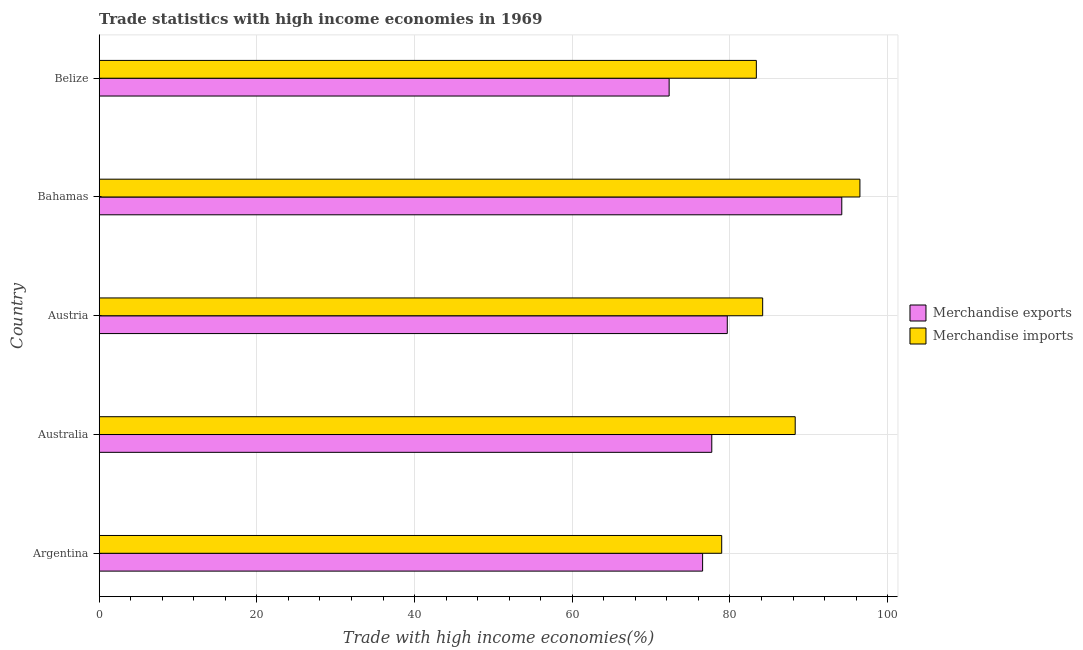How many different coloured bars are there?
Provide a succinct answer. 2. Are the number of bars per tick equal to the number of legend labels?
Your answer should be compact. Yes. How many bars are there on the 3rd tick from the top?
Offer a terse response. 2. In how many cases, is the number of bars for a given country not equal to the number of legend labels?
Ensure brevity in your answer.  0. What is the merchandise imports in Bahamas?
Offer a very short reply. 96.48. Across all countries, what is the maximum merchandise imports?
Give a very brief answer. 96.48. Across all countries, what is the minimum merchandise exports?
Your answer should be very brief. 72.28. In which country was the merchandise imports maximum?
Provide a succinct answer. Bahamas. In which country was the merchandise exports minimum?
Ensure brevity in your answer.  Belize. What is the total merchandise imports in the graph?
Give a very brief answer. 431.2. What is the difference between the merchandise imports in Australia and that in Austria?
Keep it short and to the point. 4.13. What is the difference between the merchandise exports in Australia and the merchandise imports in Austria?
Offer a very short reply. -6.45. What is the average merchandise exports per country?
Keep it short and to the point. 80.07. What is the difference between the merchandise imports and merchandise exports in Austria?
Offer a very short reply. 4.49. In how many countries, is the merchandise exports greater than 52 %?
Your answer should be compact. 5. What is the ratio of the merchandise exports in Australia to that in Bahamas?
Your response must be concise. 0.82. Is the merchandise exports in Bahamas less than that in Belize?
Your answer should be very brief. No. Is the difference between the merchandise imports in Argentina and Australia greater than the difference between the merchandise exports in Argentina and Australia?
Your answer should be very brief. No. What is the difference between the highest and the second highest merchandise exports?
Provide a short and direct response. 14.52. What is the difference between the highest and the lowest merchandise imports?
Ensure brevity in your answer.  17.53. What does the 1st bar from the bottom in Argentina represents?
Offer a terse response. Merchandise exports. How many bars are there?
Ensure brevity in your answer.  10. How many countries are there in the graph?
Offer a terse response. 5. Are the values on the major ticks of X-axis written in scientific E-notation?
Offer a very short reply. No. Does the graph contain any zero values?
Keep it short and to the point. No. Does the graph contain grids?
Your response must be concise. Yes. Where does the legend appear in the graph?
Your answer should be compact. Center right. How many legend labels are there?
Offer a very short reply. 2. What is the title of the graph?
Provide a short and direct response. Trade statistics with high income economies in 1969. What is the label or title of the X-axis?
Your response must be concise. Trade with high income economies(%). What is the label or title of the Y-axis?
Make the answer very short. Country. What is the Trade with high income economies(%) of Merchandise exports in Argentina?
Your response must be concise. 76.53. What is the Trade with high income economies(%) of Merchandise imports in Argentina?
Make the answer very short. 78.95. What is the Trade with high income economies(%) of Merchandise exports in Australia?
Provide a succinct answer. 77.69. What is the Trade with high income economies(%) of Merchandise imports in Australia?
Give a very brief answer. 88.27. What is the Trade with high income economies(%) in Merchandise exports in Austria?
Make the answer very short. 79.66. What is the Trade with high income economies(%) in Merchandise imports in Austria?
Make the answer very short. 84.15. What is the Trade with high income economies(%) of Merchandise exports in Bahamas?
Make the answer very short. 94.18. What is the Trade with high income economies(%) in Merchandise imports in Bahamas?
Your response must be concise. 96.48. What is the Trade with high income economies(%) in Merchandise exports in Belize?
Provide a short and direct response. 72.28. What is the Trade with high income economies(%) of Merchandise imports in Belize?
Provide a short and direct response. 83.35. Across all countries, what is the maximum Trade with high income economies(%) of Merchandise exports?
Offer a very short reply. 94.18. Across all countries, what is the maximum Trade with high income economies(%) in Merchandise imports?
Your answer should be very brief. 96.48. Across all countries, what is the minimum Trade with high income economies(%) in Merchandise exports?
Your answer should be very brief. 72.28. Across all countries, what is the minimum Trade with high income economies(%) of Merchandise imports?
Provide a succinct answer. 78.95. What is the total Trade with high income economies(%) of Merchandise exports in the graph?
Your answer should be compact. 400.35. What is the total Trade with high income economies(%) in Merchandise imports in the graph?
Your response must be concise. 431.2. What is the difference between the Trade with high income economies(%) in Merchandise exports in Argentina and that in Australia?
Your answer should be compact. -1.16. What is the difference between the Trade with high income economies(%) in Merchandise imports in Argentina and that in Australia?
Keep it short and to the point. -9.32. What is the difference between the Trade with high income economies(%) in Merchandise exports in Argentina and that in Austria?
Your answer should be compact. -3.13. What is the difference between the Trade with high income economies(%) of Merchandise imports in Argentina and that in Austria?
Ensure brevity in your answer.  -5.19. What is the difference between the Trade with high income economies(%) of Merchandise exports in Argentina and that in Bahamas?
Your answer should be compact. -17.65. What is the difference between the Trade with high income economies(%) in Merchandise imports in Argentina and that in Bahamas?
Provide a short and direct response. -17.53. What is the difference between the Trade with high income economies(%) of Merchandise exports in Argentina and that in Belize?
Offer a very short reply. 4.24. What is the difference between the Trade with high income economies(%) in Merchandise imports in Argentina and that in Belize?
Keep it short and to the point. -4.39. What is the difference between the Trade with high income economies(%) in Merchandise exports in Australia and that in Austria?
Your response must be concise. -1.97. What is the difference between the Trade with high income economies(%) in Merchandise imports in Australia and that in Austria?
Ensure brevity in your answer.  4.13. What is the difference between the Trade with high income economies(%) of Merchandise exports in Australia and that in Bahamas?
Provide a short and direct response. -16.49. What is the difference between the Trade with high income economies(%) of Merchandise imports in Australia and that in Bahamas?
Ensure brevity in your answer.  -8.21. What is the difference between the Trade with high income economies(%) in Merchandise exports in Australia and that in Belize?
Ensure brevity in your answer.  5.41. What is the difference between the Trade with high income economies(%) in Merchandise imports in Australia and that in Belize?
Provide a short and direct response. 4.93. What is the difference between the Trade with high income economies(%) in Merchandise exports in Austria and that in Bahamas?
Your answer should be very brief. -14.52. What is the difference between the Trade with high income economies(%) in Merchandise imports in Austria and that in Bahamas?
Provide a short and direct response. -12.34. What is the difference between the Trade with high income economies(%) in Merchandise exports in Austria and that in Belize?
Ensure brevity in your answer.  7.38. What is the difference between the Trade with high income economies(%) of Merchandise imports in Austria and that in Belize?
Ensure brevity in your answer.  0.8. What is the difference between the Trade with high income economies(%) in Merchandise exports in Bahamas and that in Belize?
Make the answer very short. 21.9. What is the difference between the Trade with high income economies(%) in Merchandise imports in Bahamas and that in Belize?
Provide a short and direct response. 13.14. What is the difference between the Trade with high income economies(%) in Merchandise exports in Argentina and the Trade with high income economies(%) in Merchandise imports in Australia?
Give a very brief answer. -11.74. What is the difference between the Trade with high income economies(%) of Merchandise exports in Argentina and the Trade with high income economies(%) of Merchandise imports in Austria?
Provide a short and direct response. -7.62. What is the difference between the Trade with high income economies(%) in Merchandise exports in Argentina and the Trade with high income economies(%) in Merchandise imports in Bahamas?
Give a very brief answer. -19.95. What is the difference between the Trade with high income economies(%) in Merchandise exports in Argentina and the Trade with high income economies(%) in Merchandise imports in Belize?
Your answer should be compact. -6.82. What is the difference between the Trade with high income economies(%) of Merchandise exports in Australia and the Trade with high income economies(%) of Merchandise imports in Austria?
Make the answer very short. -6.45. What is the difference between the Trade with high income economies(%) in Merchandise exports in Australia and the Trade with high income economies(%) in Merchandise imports in Bahamas?
Make the answer very short. -18.79. What is the difference between the Trade with high income economies(%) of Merchandise exports in Australia and the Trade with high income economies(%) of Merchandise imports in Belize?
Offer a terse response. -5.65. What is the difference between the Trade with high income economies(%) in Merchandise exports in Austria and the Trade with high income economies(%) in Merchandise imports in Bahamas?
Keep it short and to the point. -16.82. What is the difference between the Trade with high income economies(%) in Merchandise exports in Austria and the Trade with high income economies(%) in Merchandise imports in Belize?
Give a very brief answer. -3.69. What is the difference between the Trade with high income economies(%) in Merchandise exports in Bahamas and the Trade with high income economies(%) in Merchandise imports in Belize?
Provide a succinct answer. 10.84. What is the average Trade with high income economies(%) of Merchandise exports per country?
Give a very brief answer. 80.07. What is the average Trade with high income economies(%) of Merchandise imports per country?
Your response must be concise. 86.24. What is the difference between the Trade with high income economies(%) in Merchandise exports and Trade with high income economies(%) in Merchandise imports in Argentina?
Ensure brevity in your answer.  -2.42. What is the difference between the Trade with high income economies(%) of Merchandise exports and Trade with high income economies(%) of Merchandise imports in Australia?
Your answer should be very brief. -10.58. What is the difference between the Trade with high income economies(%) in Merchandise exports and Trade with high income economies(%) in Merchandise imports in Austria?
Keep it short and to the point. -4.49. What is the difference between the Trade with high income economies(%) in Merchandise exports and Trade with high income economies(%) in Merchandise imports in Bahamas?
Keep it short and to the point. -2.3. What is the difference between the Trade with high income economies(%) of Merchandise exports and Trade with high income economies(%) of Merchandise imports in Belize?
Your response must be concise. -11.06. What is the ratio of the Trade with high income economies(%) in Merchandise exports in Argentina to that in Australia?
Provide a short and direct response. 0.98. What is the ratio of the Trade with high income economies(%) in Merchandise imports in Argentina to that in Australia?
Your response must be concise. 0.89. What is the ratio of the Trade with high income economies(%) of Merchandise exports in Argentina to that in Austria?
Your response must be concise. 0.96. What is the ratio of the Trade with high income economies(%) of Merchandise imports in Argentina to that in Austria?
Offer a terse response. 0.94. What is the ratio of the Trade with high income economies(%) in Merchandise exports in Argentina to that in Bahamas?
Provide a short and direct response. 0.81. What is the ratio of the Trade with high income economies(%) of Merchandise imports in Argentina to that in Bahamas?
Offer a terse response. 0.82. What is the ratio of the Trade with high income economies(%) in Merchandise exports in Argentina to that in Belize?
Your answer should be very brief. 1.06. What is the ratio of the Trade with high income economies(%) in Merchandise imports in Argentina to that in Belize?
Offer a terse response. 0.95. What is the ratio of the Trade with high income economies(%) of Merchandise exports in Australia to that in Austria?
Give a very brief answer. 0.98. What is the ratio of the Trade with high income economies(%) of Merchandise imports in Australia to that in Austria?
Ensure brevity in your answer.  1.05. What is the ratio of the Trade with high income economies(%) in Merchandise exports in Australia to that in Bahamas?
Offer a very short reply. 0.82. What is the ratio of the Trade with high income economies(%) in Merchandise imports in Australia to that in Bahamas?
Your answer should be compact. 0.91. What is the ratio of the Trade with high income economies(%) in Merchandise exports in Australia to that in Belize?
Keep it short and to the point. 1.07. What is the ratio of the Trade with high income economies(%) in Merchandise imports in Australia to that in Belize?
Provide a succinct answer. 1.06. What is the ratio of the Trade with high income economies(%) of Merchandise exports in Austria to that in Bahamas?
Give a very brief answer. 0.85. What is the ratio of the Trade with high income economies(%) in Merchandise imports in Austria to that in Bahamas?
Provide a succinct answer. 0.87. What is the ratio of the Trade with high income economies(%) of Merchandise exports in Austria to that in Belize?
Your answer should be compact. 1.1. What is the ratio of the Trade with high income economies(%) of Merchandise imports in Austria to that in Belize?
Provide a succinct answer. 1.01. What is the ratio of the Trade with high income economies(%) in Merchandise exports in Bahamas to that in Belize?
Make the answer very short. 1.3. What is the ratio of the Trade with high income economies(%) in Merchandise imports in Bahamas to that in Belize?
Offer a terse response. 1.16. What is the difference between the highest and the second highest Trade with high income economies(%) in Merchandise exports?
Ensure brevity in your answer.  14.52. What is the difference between the highest and the second highest Trade with high income economies(%) in Merchandise imports?
Offer a very short reply. 8.21. What is the difference between the highest and the lowest Trade with high income economies(%) in Merchandise exports?
Provide a succinct answer. 21.9. What is the difference between the highest and the lowest Trade with high income economies(%) of Merchandise imports?
Offer a terse response. 17.53. 